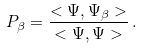<formula> <loc_0><loc_0><loc_500><loc_500>P _ { \beta } = \frac { < \Psi , \Psi _ { \beta } > } { < \Psi , \Psi > } \, .</formula> 